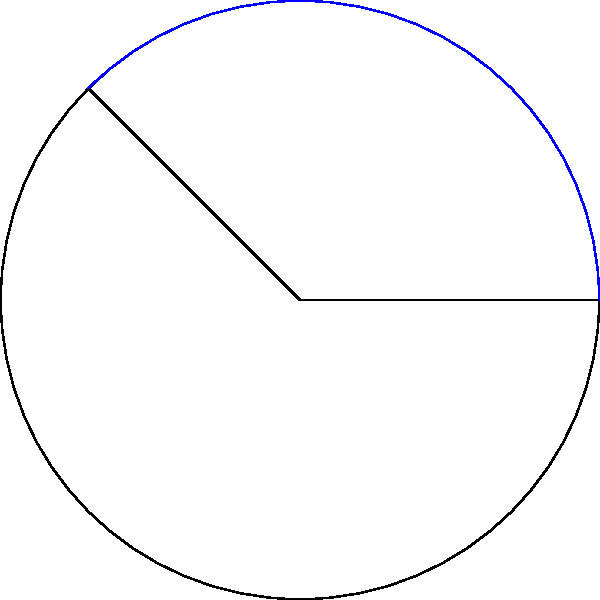In the circular sector shown above, the radius of the circle is 3 units, and the central angle is 135°. Calculate the area of this sector, expressing your answer in terms of π. How might this calculation relate to the distribution of educational resources across different political ideologies? Let's approach this step-by-step:

1) The formula for the area of a circular sector is:

   $$A = \frac{\theta}{360°} \cdot \pi r^2$$

   Where $\theta$ is the central angle in degrees, and $r$ is the radius.

2) We're given:
   $r = 3$ units
   $\theta = 135°$

3) Substituting these values into the formula:

   $$A = \frac{135°}{360°} \cdot \pi (3)^2$$

4) Simplify:
   $$A = \frac{3}{8} \cdot \pi \cdot 9$$
   $$A = \frac{27}{8} \pi$$

5) This can be further simplified to:
   $$A = \frac{27\pi}{8}$$ square units

Relating to education and political ideology:
This calculation method, where we consider a fraction of the whole (135° out of 360°), could be analogous to how educational resources might be distributed across different political ideologies. Just as the sector represents a portion of the circle's area, different political perspectives might receive varying amounts of attention or resources in educational settings. The challenge lies in determining what a "fair" distribution would look like, much like how we calculate the precise area of a sector based on its proportion of the whole circle.
Answer: $\frac{27\pi}{8}$ square units 